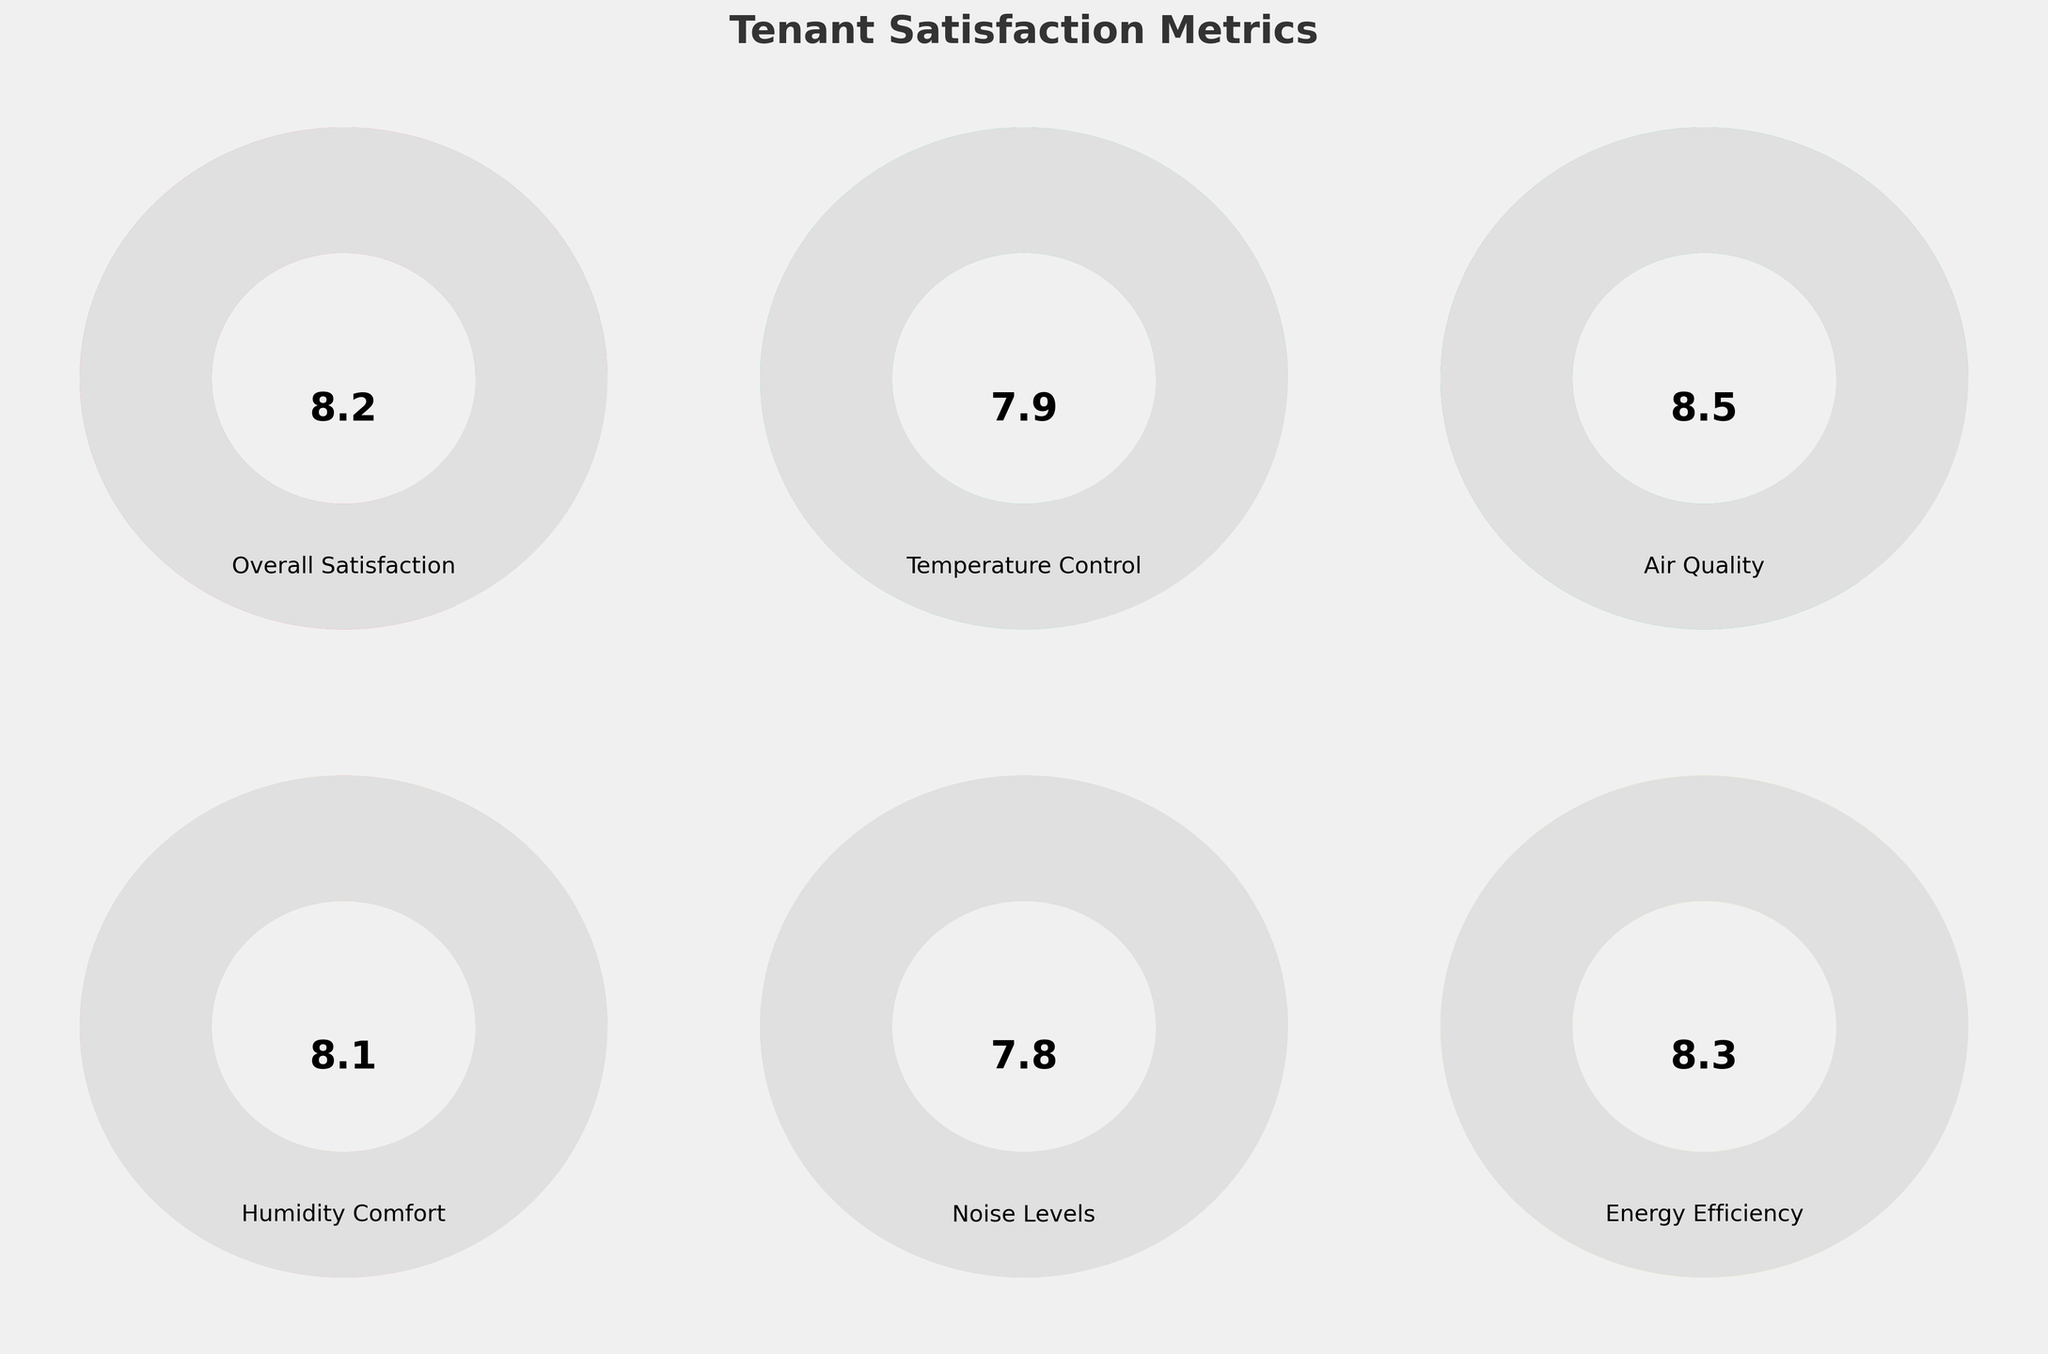What is the title of the figure? The title is located at the top center of the plot area and is typically in a larger, bold font for easy identification. In this figure, it reads 'Tenant Satisfaction Metrics'.
Answer: Tenant Satisfaction Metrics Which tenant satisfaction metric has the highest score? By examining the value texts inside the gauge charts, the metric with the highest score is 'Air Quality' with a value of 8.5.
Answer: Air Quality What is the score for Temperature Control? Look for the gauge labeled 'Temperature Control' and read the numerical value displayed inside it, which is 7.9.
Answer: 7.9 Which metric has the lowest score? Compare the values shown in each gauge chart. The gauge chart for 'Noise Levels' shows the lowest score of 7.8.
Answer: Noise Levels What is the average value of all tenant satisfaction metrics? Calculate the average of all the values: (8.2 + 7.9 + 8.5 + 8.1 + 7.8 + 8.3) / 6 = 8.13.
Answer: 8.13 How does the energy efficiency score compare to the overall satisfaction score? Look at the value for 'Energy Efficiency' which is 8.3 and compare it to 'Overall Satisfaction' which is 8.2. Energy efficiency is slightly higher.
Answer: Energy Efficiency is higher Are there any metrics with a score below 8? By observing the values in each gauge, 'Temperature Control' (7.9) and 'Noise Levels' (7.8) are below 8.
Answer: Yes, Temperature Control and Noise Levels What's the difference in score between Air Quality and Noise Levels? Subtract the value of 'Noise Levels' from 'Air Quality': 8.5 - 7.8 = 0.7.
Answer: 0.7 How many metrics scored 8.0 and above? Count the gauges with scores of 8.0 and above: 'Overall Satisfaction' (8.2), 'Air Quality' (8.5), 'Humidity Comfort' (8.1), and 'Energy Efficiency' (8.3). There are 4 such metrics.
Answer: 4 What score is the closest to the midpoint of the scale (5)? Locate the score values and find the one nearest to 5. All scores are significantly higher than 5, but the closest is 'Noise Levels' at 7.8.
Answer: Noise Levels 